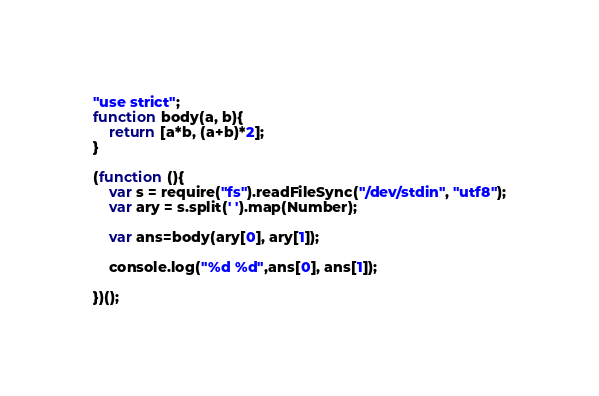Convert code to text. <code><loc_0><loc_0><loc_500><loc_500><_JavaScript_>"use strict";
function body(a, b){
    return [a*b, (a+b)*2];
}

(function (){
    var s = require("fs").readFileSync("/dev/stdin", "utf8");
    var ary = s.split(' ').map(Number);

    var ans=body(ary[0], ary[1]);
    
    console.log("%d %d",ans[0], ans[1]);

})();
</code> 